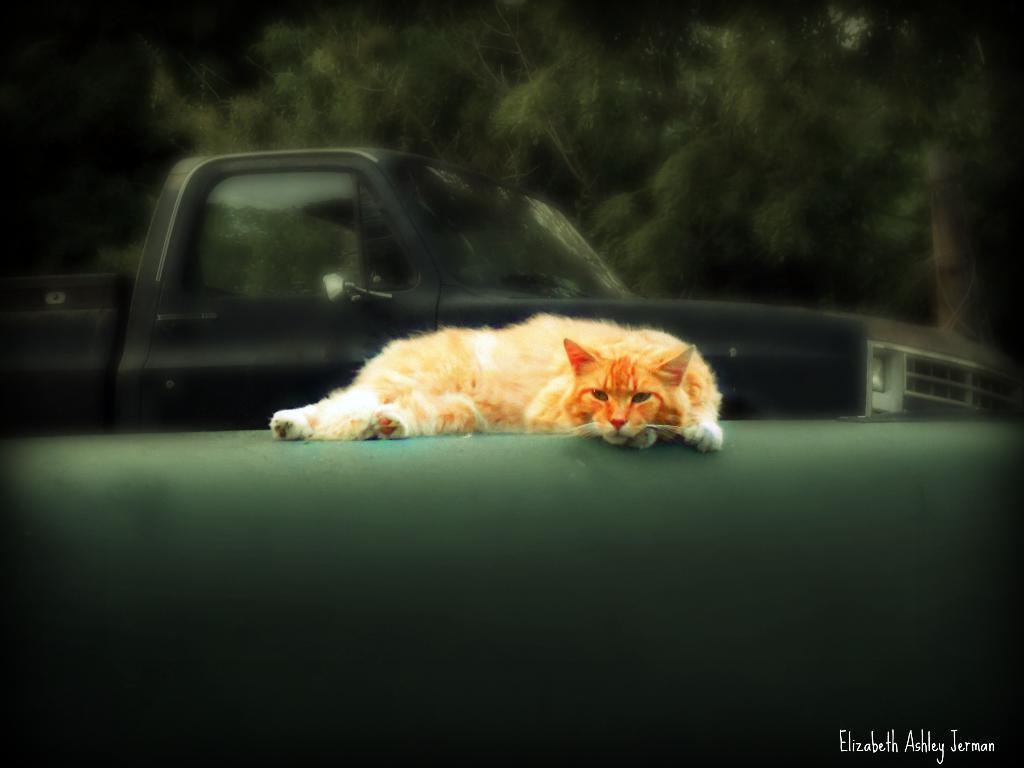What type of animal is in the image? There is a cat in the image. What can be seen in the background of the image? There is a truck and trees in the background of the image. What type of nut is the cat holding in the image? There is no nut present in the image; the cat is not holding anything. 